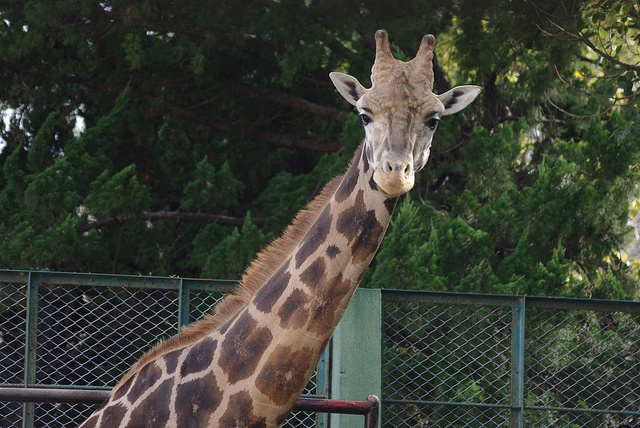Describe the objects in this image and their specific colors. I can see a giraffe in black, gray, and darkgray tones in this image. 